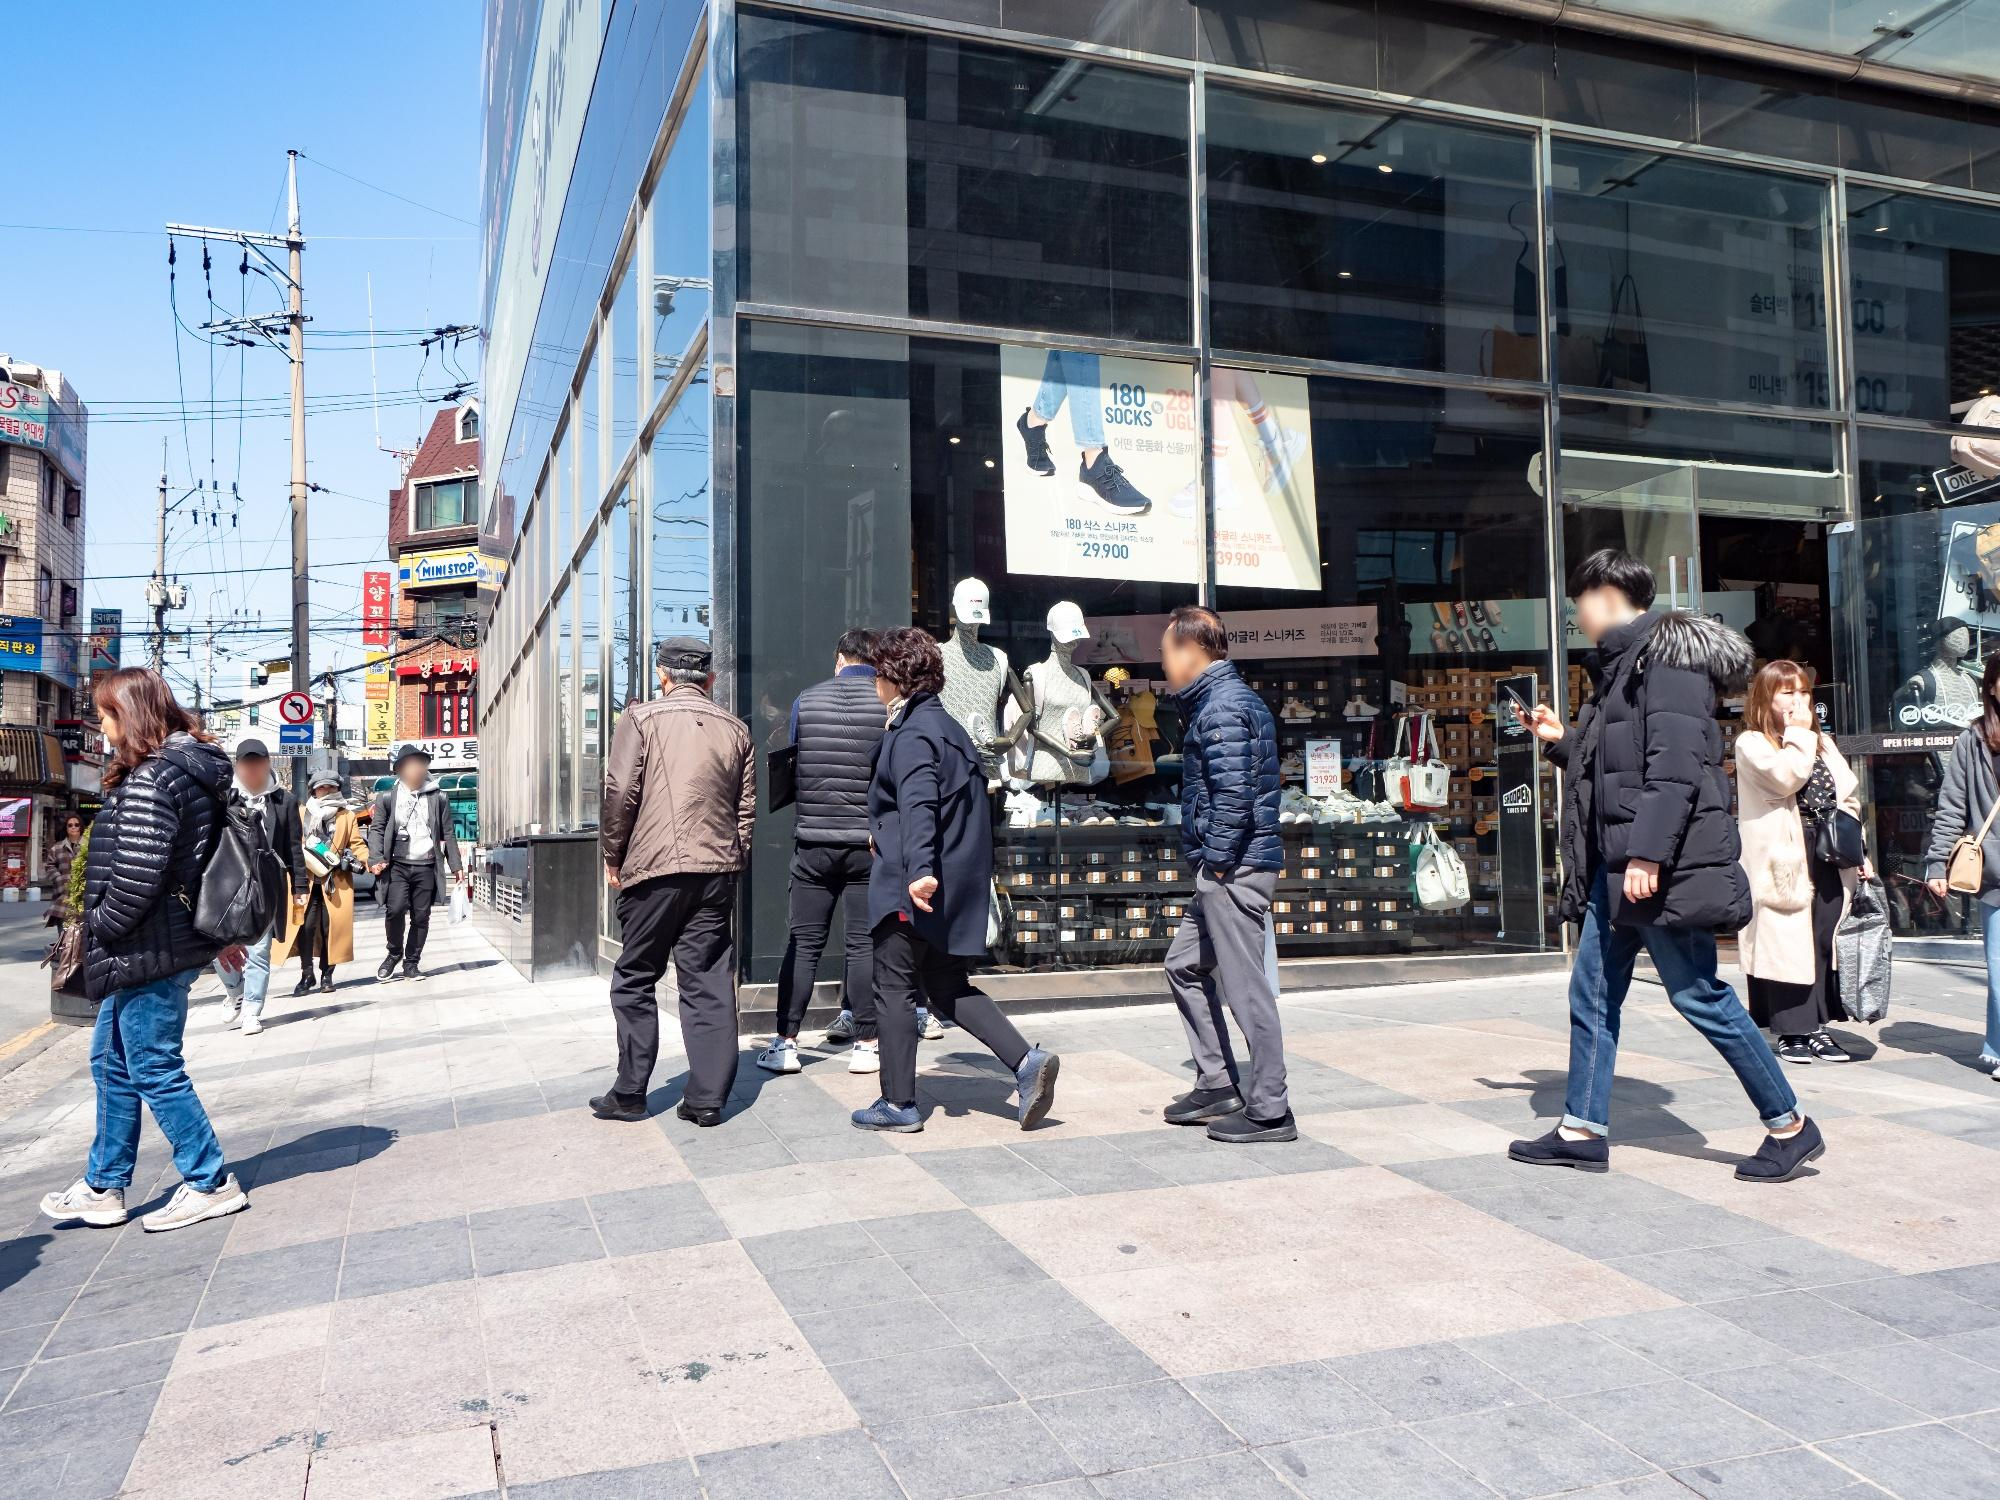What do you see happening in this image? The image showcases a lively urban scene on a sunny day in Japan, likely in a bustling shopping district. People of various ages are seen walking, some in groups and others alone, reflecting the daily rhythm of city life. The street is flanked by modern buildings with glass facades, featuring a variety of shops including a prominent display of socks and accessories in one, highlighting the commercial nature of the area. Signs in Japanese enhance the local flavor, and the clear blue sky adds vibrancy to the busy urban landscape. The interaction among pedestrians and their varied attire suggest a casual yet fashionable urban culture prevalent in modern Japanese cities. 